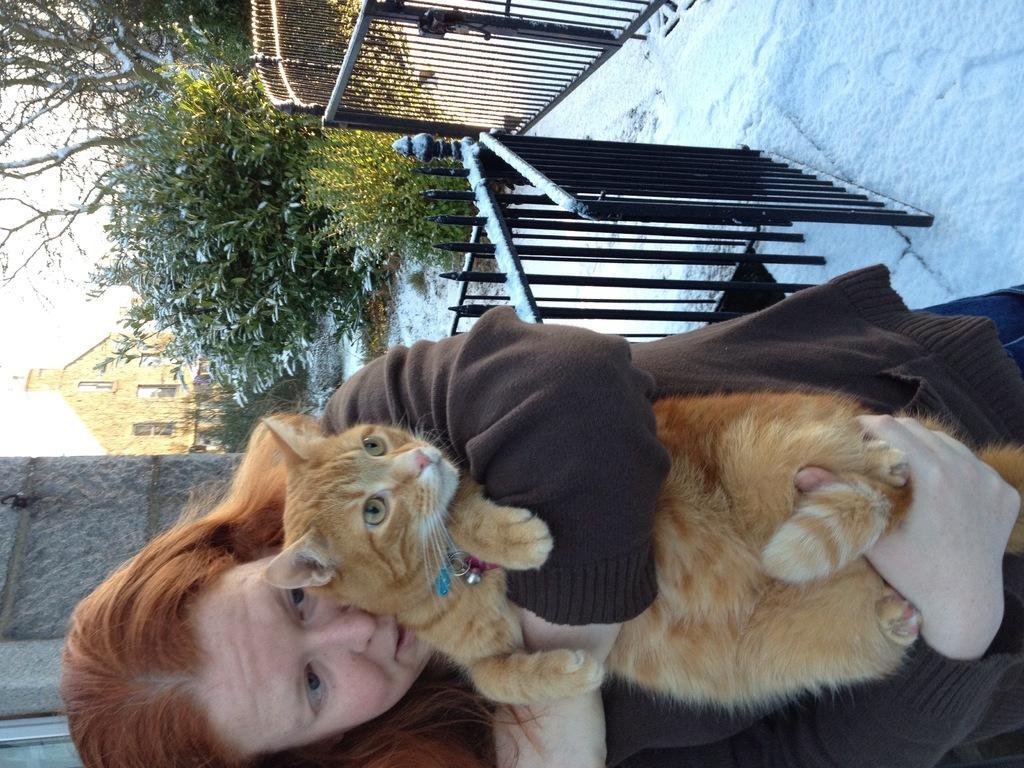Can you describe this image briefly? Here in this picture we can see a woman standing on the ground, which is fully covered with snow over there and we can see she is holding a cat in her arms and behind her we can see railing present here and there and we can see plants and trees present all over there and in the far we can see a church present over there. 